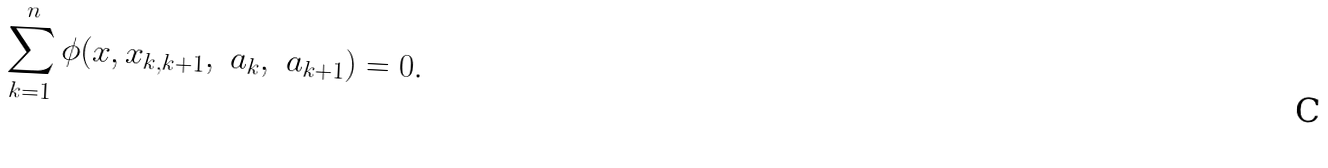Convert formula to latex. <formula><loc_0><loc_0><loc_500><loc_500>\sum _ { k = 1 } ^ { n } \phi ( x , x _ { k , k + 1 } , \ a _ { k } , \ a _ { k + 1 } ) = 0 .</formula> 